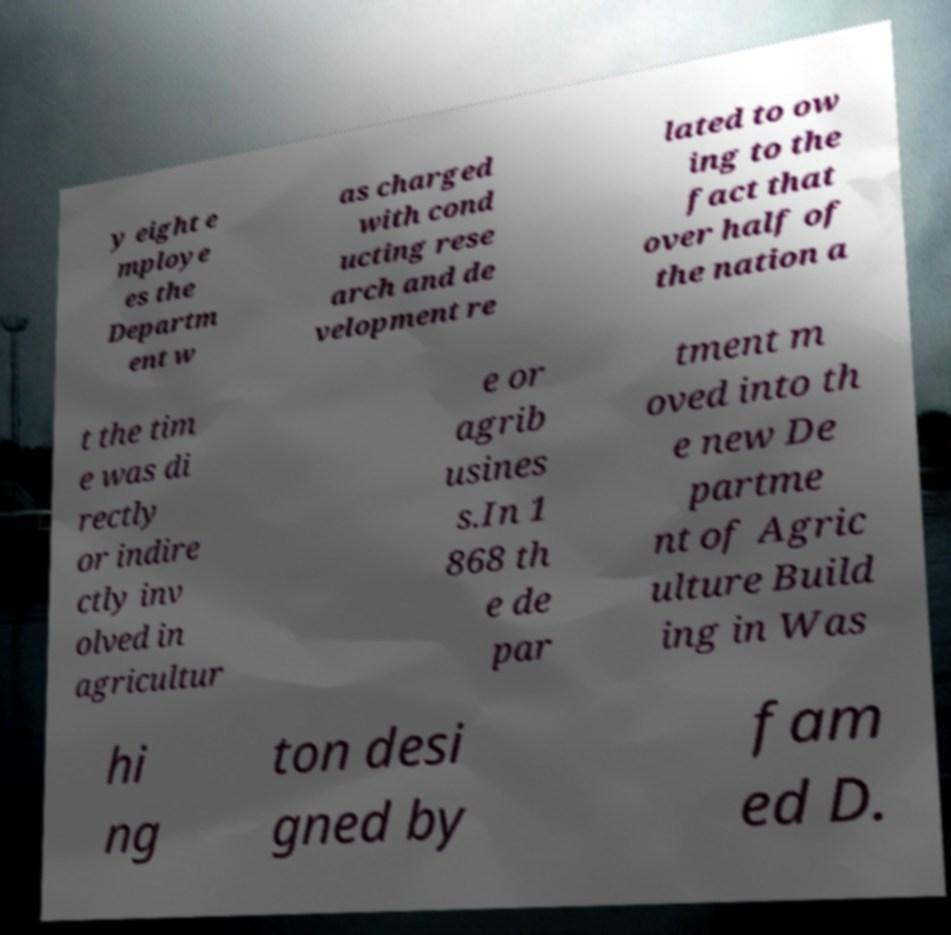Could you extract and type out the text from this image? y eight e mploye es the Departm ent w as charged with cond ucting rese arch and de velopment re lated to ow ing to the fact that over half of the nation a t the tim e was di rectly or indire ctly inv olved in agricultur e or agrib usines s.In 1 868 th e de par tment m oved into th e new De partme nt of Agric ulture Build ing in Was hi ng ton desi gned by fam ed D. 